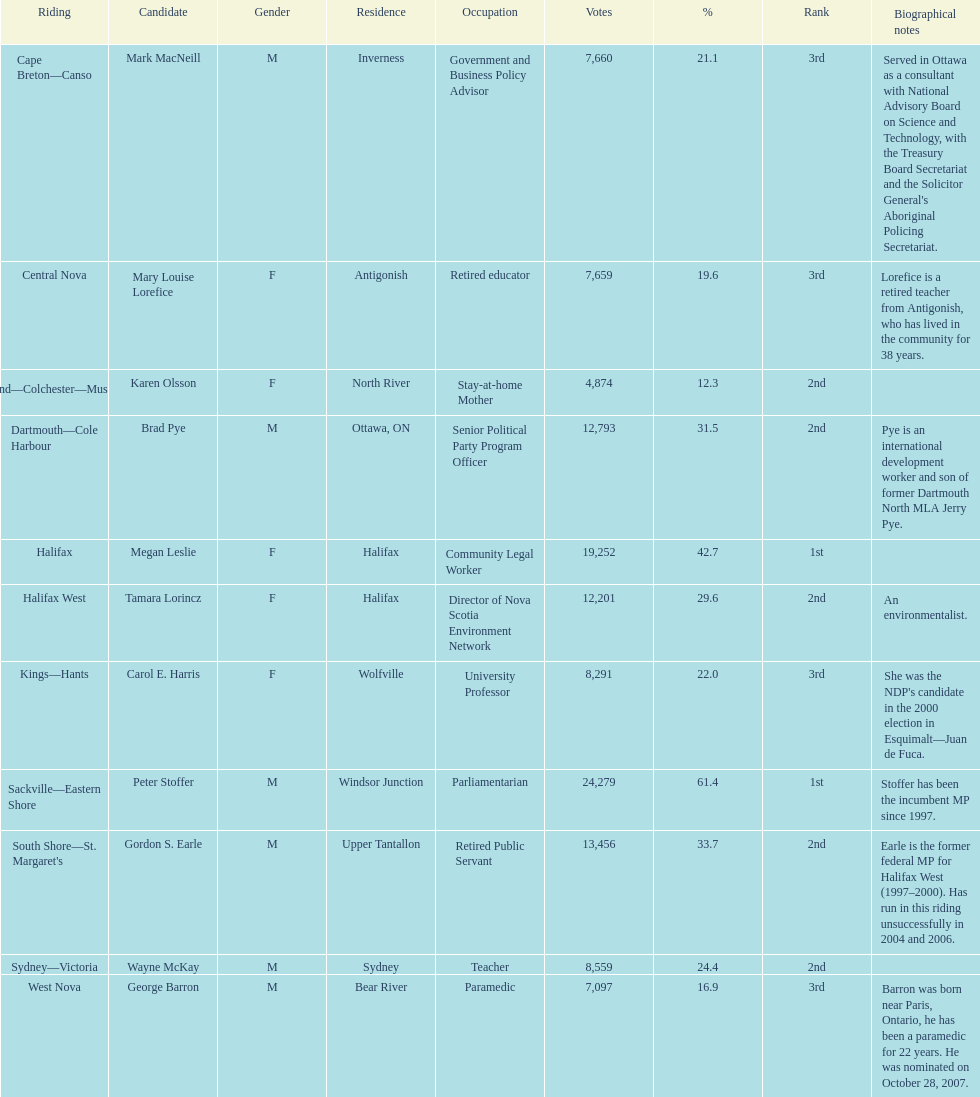What is the first riding? Cape Breton-Canso. 